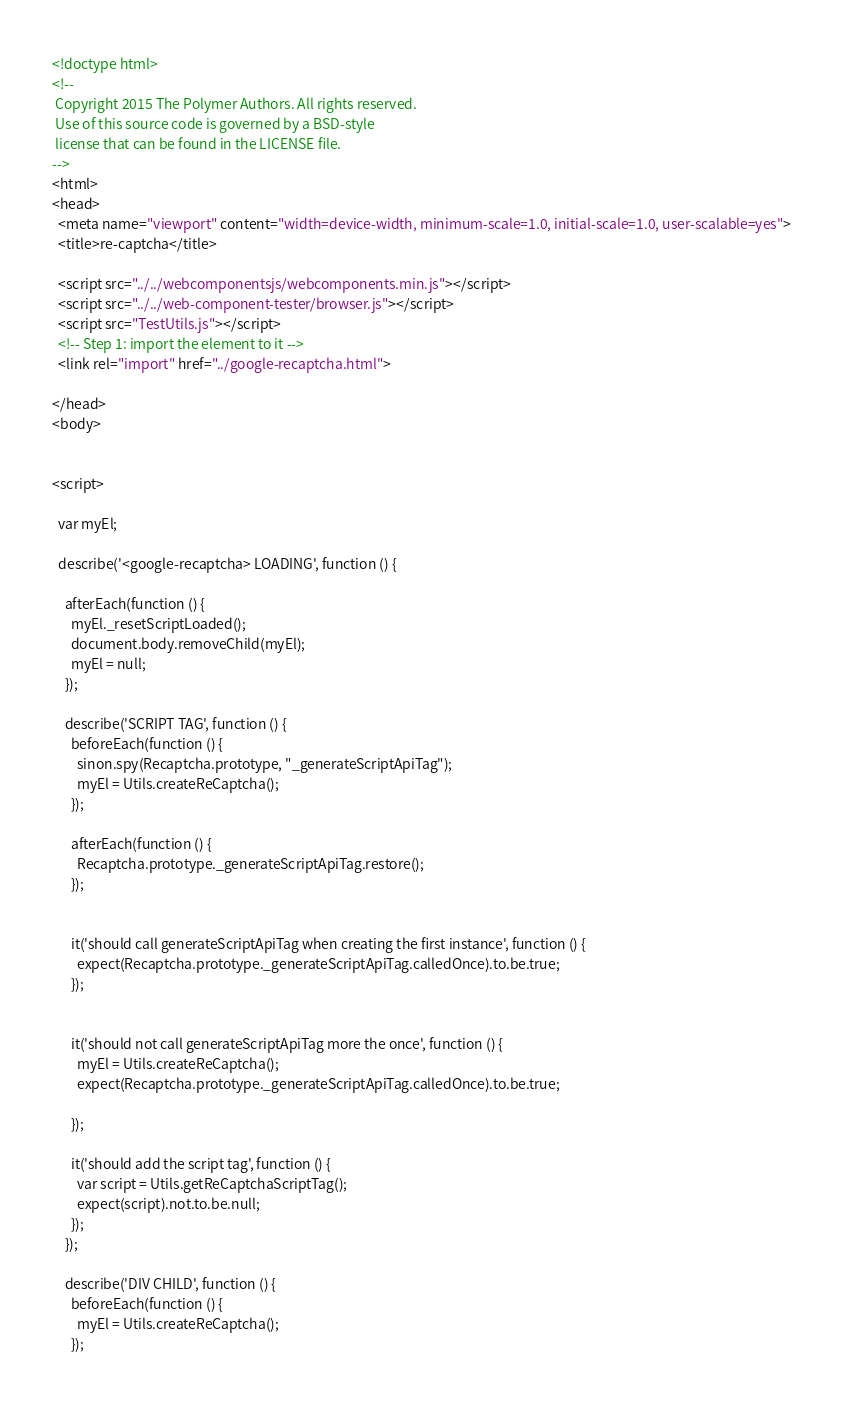Convert code to text. <code><loc_0><loc_0><loc_500><loc_500><_HTML_><!doctype html>
<!--
 Copyright 2015 The Polymer Authors. All rights reserved.
 Use of this source code is governed by a BSD-style
 license that can be found in the LICENSE file.
-->
<html>
<head>
  <meta name="viewport" content="width=device-width, minimum-scale=1.0, initial-scale=1.0, user-scalable=yes">
  <title>re-captcha</title>

  <script src="../../webcomponentsjs/webcomponents.min.js"></script>
  <script src="../../web-component-tester/browser.js"></script>
  <script src="TestUtils.js"></script>
  <!-- Step 1: import the element to it -->
  <link rel="import" href="../google-recaptcha.html">

</head>
<body>


<script>

  var myEl;

  describe('<google-recaptcha> LOADING', function () {

    afterEach(function () {
      myEl._resetScriptLoaded();
      document.body.removeChild(myEl);
      myEl = null;
    });

    describe('SCRIPT TAG', function () {
      beforeEach(function () {
        sinon.spy(Recaptcha.prototype, "_generateScriptApiTag");
        myEl = Utils.createReCaptcha();
      });

      afterEach(function () {
        Recaptcha.prototype._generateScriptApiTag.restore();
      });


      it('should call generateScriptApiTag when creating the first instance', function () {
        expect(Recaptcha.prototype._generateScriptApiTag.calledOnce).to.be.true;
      });


      it('should not call generateScriptApiTag more the once', function () {
        myEl = Utils.createReCaptcha();
        expect(Recaptcha.prototype._generateScriptApiTag.calledOnce).to.be.true;

      });

      it('should add the script tag', function () {
        var script = Utils.getReCaptchaScriptTag();
        expect(script).not.to.be.null;
      });
    });

    describe('DIV CHILD', function () {
      beforeEach(function () {
        myEl = Utils.createReCaptcha();
      });
</code> 